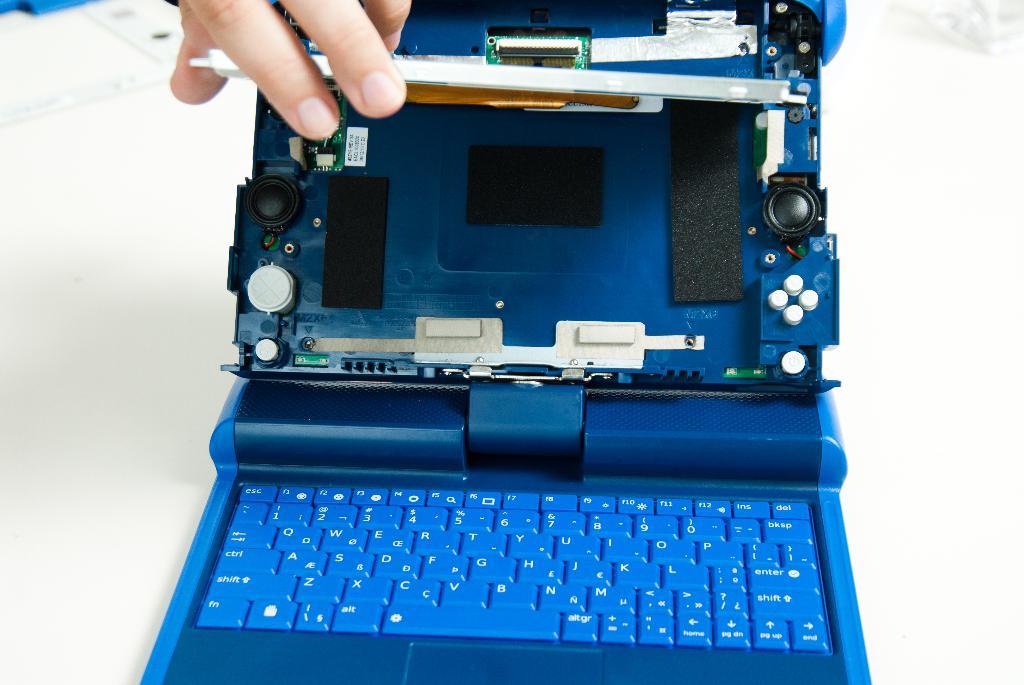What is the key on the bottom left of the keyboard?
Your response must be concise. Fn. What key is on the top right hand corner of this keyboard?
Provide a short and direct response. Del. 